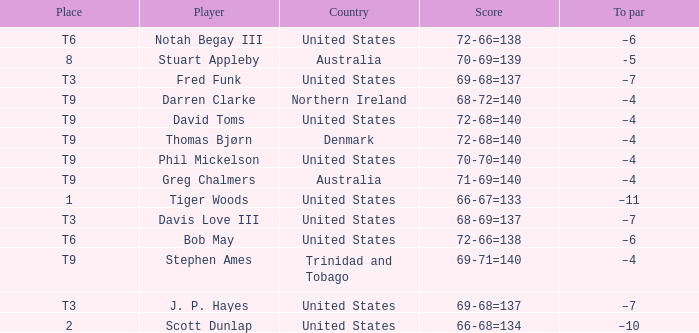What place did Bob May get when his score was 72-66=138? T6. 